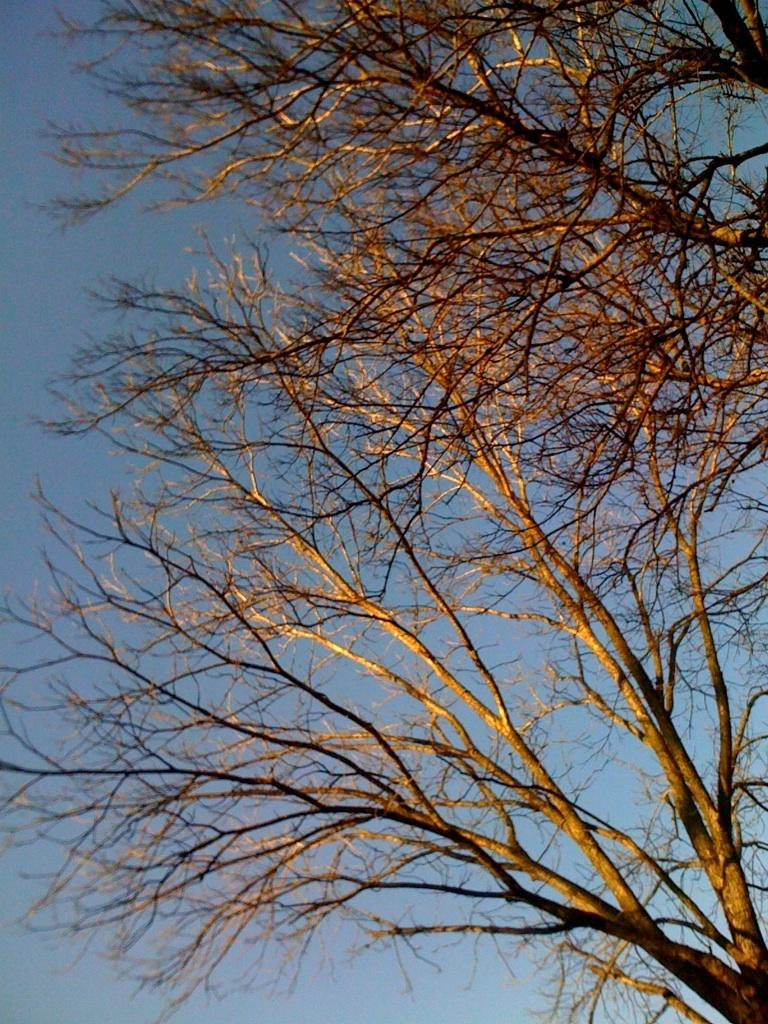What type of vegetation can be seen in the image? There are trees in the image. What is visible at the top of the image? The sky is visible at the top of the image. What is the condition of the trees in the image? The trees have no leaves. How many chess pieces can be seen on the trees in the image? There are no chess pieces present in the image; it only features trees and the sky. 